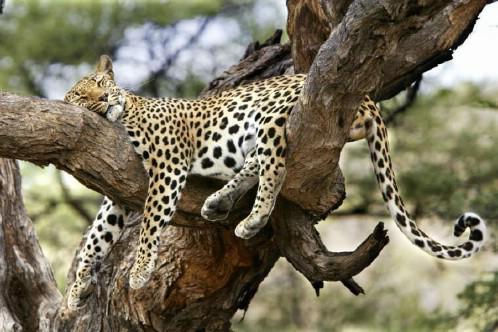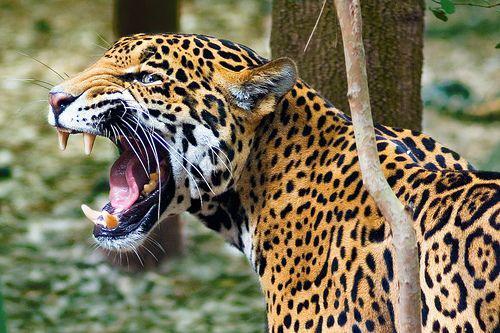The first image is the image on the left, the second image is the image on the right. Analyze the images presented: Is the assertion "At least one animal is sleeping in a tree." valid? Answer yes or no. Yes. 